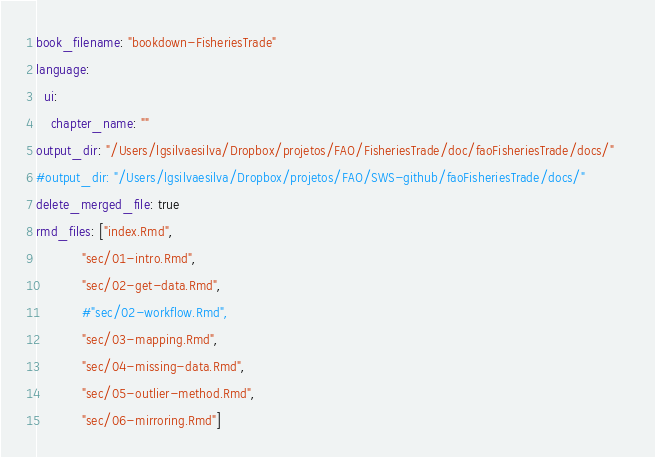<code> <loc_0><loc_0><loc_500><loc_500><_YAML_>book_filename: "bookdown-FisheriesTrade"
language:
  ui:
    chapter_name: ""
output_dir: "/Users/lgsilvaesilva/Dropbox/projetos/FAO/FisheriesTrade/doc/faoFisheriesTrade/docs/"    
#output_dir: "/Users/lgsilvaesilva/Dropbox/projetos/FAO/SWS-github/faoFisheriesTrade/docs/"    
delete_merged_file: true
rmd_files: ["index.Rmd", 
            "sec/01-intro.Rmd", 
            "sec/02-get-data.Rmd",
            #"sec/02-workflow.Rmd", 
            "sec/03-mapping.Rmd",
            "sec/04-missing-data.Rmd",
            "sec/05-outlier-method.Rmd",
            "sec/06-mirroring.Rmd"]
</code> 